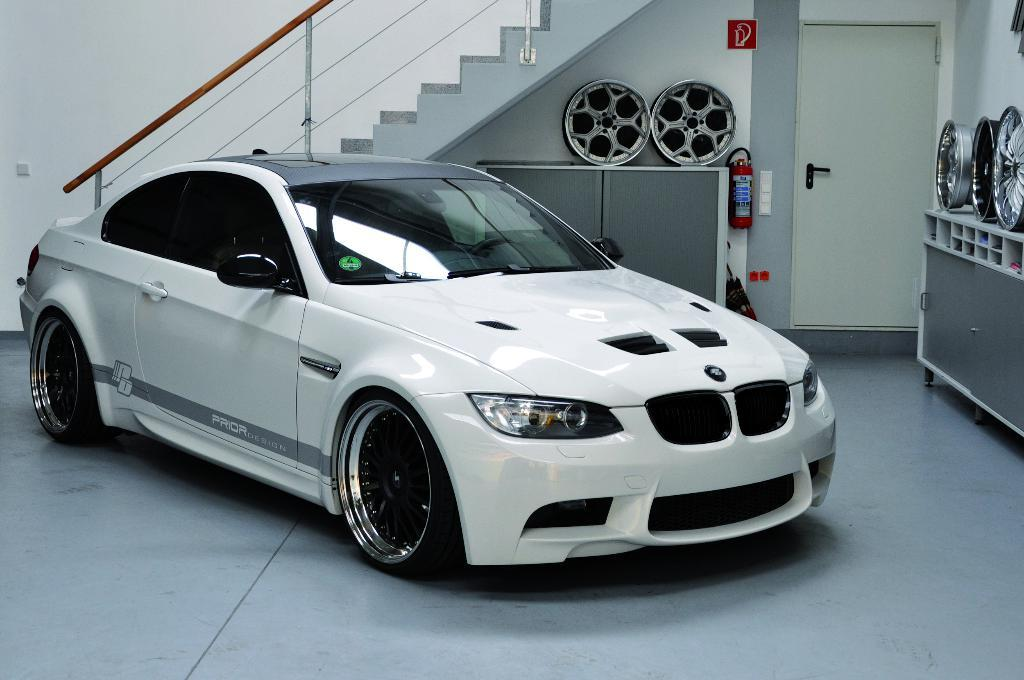What is parked in the image? There is a car parked in the image. Where is the car located? The car is on the floor. What can be seen in the background of the image? There is a staircase, cupboards, and wheels visible in the background of the image. What safety device is present on the wall in the background of the image? There is a fire extinguisher on the wall in the background of the image. Can you see any hands holding a whip in the image? There are no hands or whips present in the image. 